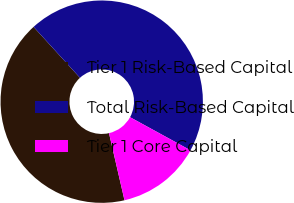<chart> <loc_0><loc_0><loc_500><loc_500><pie_chart><fcel>Tier 1 Risk-Based Capital<fcel>Total Risk-Based Capital<fcel>Tier 1 Core Capital<nl><fcel>41.85%<fcel>44.74%<fcel>13.41%<nl></chart> 